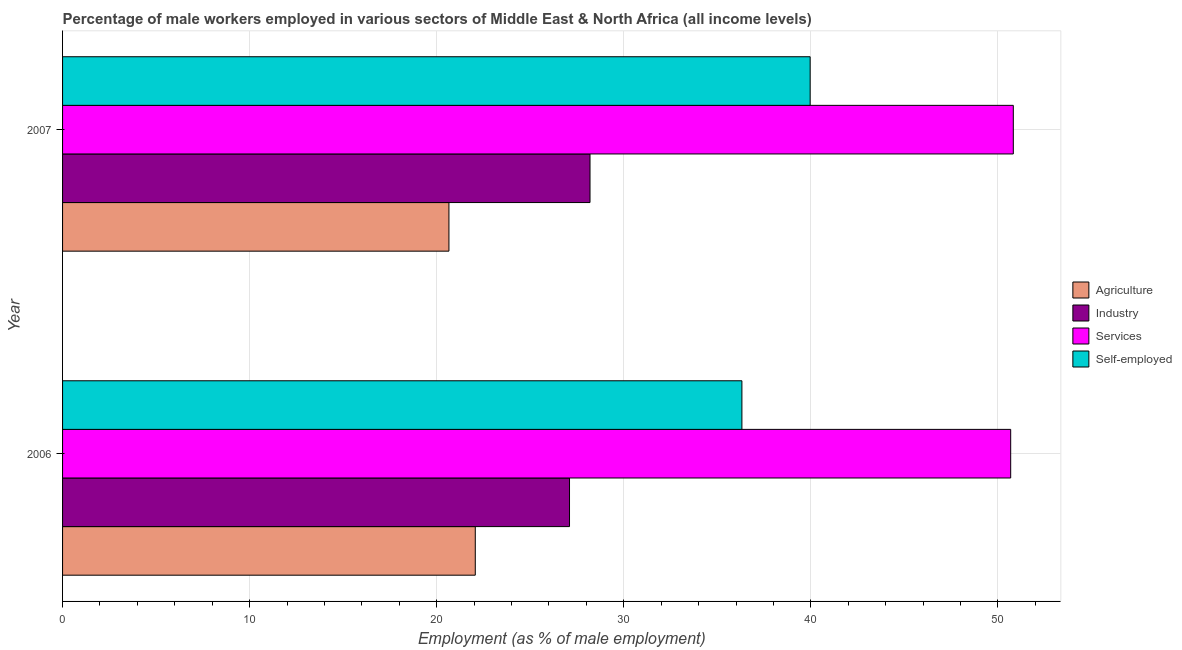How many different coloured bars are there?
Provide a succinct answer. 4. How many groups of bars are there?
Give a very brief answer. 2. How many bars are there on the 1st tick from the top?
Your answer should be compact. 4. What is the label of the 1st group of bars from the top?
Your answer should be very brief. 2007. What is the percentage of male workers in industry in 2006?
Make the answer very short. 27.1. Across all years, what is the maximum percentage of self employed male workers?
Provide a short and direct response. 39.96. Across all years, what is the minimum percentage of male workers in industry?
Your answer should be very brief. 27.1. What is the total percentage of male workers in agriculture in the graph?
Provide a short and direct response. 42.72. What is the difference between the percentage of self employed male workers in 2006 and that in 2007?
Keep it short and to the point. -3.65. What is the difference between the percentage of male workers in agriculture in 2006 and the percentage of male workers in services in 2007?
Your answer should be compact. -28.76. What is the average percentage of male workers in industry per year?
Provide a succinct answer. 27.65. In the year 2006, what is the difference between the percentage of male workers in industry and percentage of male workers in agriculture?
Make the answer very short. 5.04. What is the ratio of the percentage of self employed male workers in 2006 to that in 2007?
Provide a succinct answer. 0.91. Is the percentage of male workers in industry in 2006 less than that in 2007?
Provide a succinct answer. Yes. Is the difference between the percentage of male workers in services in 2006 and 2007 greater than the difference between the percentage of male workers in agriculture in 2006 and 2007?
Your answer should be very brief. No. Is it the case that in every year, the sum of the percentage of male workers in services and percentage of self employed male workers is greater than the sum of percentage of male workers in industry and percentage of male workers in agriculture?
Your answer should be compact. Yes. What does the 3rd bar from the top in 2006 represents?
Offer a very short reply. Industry. What does the 4th bar from the bottom in 2006 represents?
Provide a short and direct response. Self-employed. How many years are there in the graph?
Offer a very short reply. 2. What is the difference between two consecutive major ticks on the X-axis?
Your answer should be very brief. 10. Does the graph contain grids?
Make the answer very short. Yes. Where does the legend appear in the graph?
Provide a short and direct response. Center right. How many legend labels are there?
Make the answer very short. 4. What is the title of the graph?
Keep it short and to the point. Percentage of male workers employed in various sectors of Middle East & North Africa (all income levels). What is the label or title of the X-axis?
Ensure brevity in your answer.  Employment (as % of male employment). What is the label or title of the Y-axis?
Make the answer very short. Year. What is the Employment (as % of male employment) of Agriculture in 2006?
Give a very brief answer. 22.06. What is the Employment (as % of male employment) in Industry in 2006?
Keep it short and to the point. 27.1. What is the Employment (as % of male employment) in Services in 2006?
Provide a short and direct response. 50.68. What is the Employment (as % of male employment) in Self-employed in 2006?
Ensure brevity in your answer.  36.31. What is the Employment (as % of male employment) of Agriculture in 2007?
Your answer should be very brief. 20.65. What is the Employment (as % of male employment) in Industry in 2007?
Keep it short and to the point. 28.19. What is the Employment (as % of male employment) in Services in 2007?
Your response must be concise. 50.82. What is the Employment (as % of male employment) of Self-employed in 2007?
Keep it short and to the point. 39.96. Across all years, what is the maximum Employment (as % of male employment) in Agriculture?
Ensure brevity in your answer.  22.06. Across all years, what is the maximum Employment (as % of male employment) in Industry?
Offer a very short reply. 28.19. Across all years, what is the maximum Employment (as % of male employment) in Services?
Your answer should be very brief. 50.82. Across all years, what is the maximum Employment (as % of male employment) in Self-employed?
Offer a terse response. 39.96. Across all years, what is the minimum Employment (as % of male employment) of Agriculture?
Your answer should be compact. 20.65. Across all years, what is the minimum Employment (as % of male employment) in Industry?
Offer a terse response. 27.1. Across all years, what is the minimum Employment (as % of male employment) of Services?
Make the answer very short. 50.68. Across all years, what is the minimum Employment (as % of male employment) in Self-employed?
Your answer should be very brief. 36.31. What is the total Employment (as % of male employment) of Agriculture in the graph?
Offer a very short reply. 42.72. What is the total Employment (as % of male employment) of Industry in the graph?
Your answer should be compact. 55.29. What is the total Employment (as % of male employment) in Services in the graph?
Provide a succinct answer. 101.5. What is the total Employment (as % of male employment) of Self-employed in the graph?
Provide a short and direct response. 76.28. What is the difference between the Employment (as % of male employment) in Agriculture in 2006 and that in 2007?
Your answer should be very brief. 1.41. What is the difference between the Employment (as % of male employment) of Industry in 2006 and that in 2007?
Your answer should be very brief. -1.1. What is the difference between the Employment (as % of male employment) of Services in 2006 and that in 2007?
Offer a terse response. -0.14. What is the difference between the Employment (as % of male employment) in Self-employed in 2006 and that in 2007?
Ensure brevity in your answer.  -3.65. What is the difference between the Employment (as % of male employment) in Agriculture in 2006 and the Employment (as % of male employment) in Industry in 2007?
Keep it short and to the point. -6.13. What is the difference between the Employment (as % of male employment) of Agriculture in 2006 and the Employment (as % of male employment) of Services in 2007?
Your answer should be compact. -28.76. What is the difference between the Employment (as % of male employment) of Agriculture in 2006 and the Employment (as % of male employment) of Self-employed in 2007?
Your answer should be very brief. -17.9. What is the difference between the Employment (as % of male employment) of Industry in 2006 and the Employment (as % of male employment) of Services in 2007?
Your answer should be compact. -23.72. What is the difference between the Employment (as % of male employment) of Industry in 2006 and the Employment (as % of male employment) of Self-employed in 2007?
Offer a terse response. -12.86. What is the difference between the Employment (as % of male employment) of Services in 2006 and the Employment (as % of male employment) of Self-employed in 2007?
Offer a very short reply. 10.72. What is the average Employment (as % of male employment) in Agriculture per year?
Give a very brief answer. 21.36. What is the average Employment (as % of male employment) of Industry per year?
Keep it short and to the point. 27.65. What is the average Employment (as % of male employment) of Services per year?
Offer a very short reply. 50.75. What is the average Employment (as % of male employment) of Self-employed per year?
Ensure brevity in your answer.  38.14. In the year 2006, what is the difference between the Employment (as % of male employment) of Agriculture and Employment (as % of male employment) of Industry?
Your answer should be very brief. -5.04. In the year 2006, what is the difference between the Employment (as % of male employment) of Agriculture and Employment (as % of male employment) of Services?
Provide a short and direct response. -28.62. In the year 2006, what is the difference between the Employment (as % of male employment) in Agriculture and Employment (as % of male employment) in Self-employed?
Your answer should be very brief. -14.25. In the year 2006, what is the difference between the Employment (as % of male employment) of Industry and Employment (as % of male employment) of Services?
Keep it short and to the point. -23.58. In the year 2006, what is the difference between the Employment (as % of male employment) in Industry and Employment (as % of male employment) in Self-employed?
Offer a very short reply. -9.21. In the year 2006, what is the difference between the Employment (as % of male employment) of Services and Employment (as % of male employment) of Self-employed?
Offer a very short reply. 14.37. In the year 2007, what is the difference between the Employment (as % of male employment) in Agriculture and Employment (as % of male employment) in Industry?
Your response must be concise. -7.54. In the year 2007, what is the difference between the Employment (as % of male employment) in Agriculture and Employment (as % of male employment) in Services?
Your answer should be compact. -30.17. In the year 2007, what is the difference between the Employment (as % of male employment) of Agriculture and Employment (as % of male employment) of Self-employed?
Offer a very short reply. -19.31. In the year 2007, what is the difference between the Employment (as % of male employment) in Industry and Employment (as % of male employment) in Services?
Make the answer very short. -22.63. In the year 2007, what is the difference between the Employment (as % of male employment) of Industry and Employment (as % of male employment) of Self-employed?
Make the answer very short. -11.77. In the year 2007, what is the difference between the Employment (as % of male employment) of Services and Employment (as % of male employment) of Self-employed?
Give a very brief answer. 10.86. What is the ratio of the Employment (as % of male employment) of Agriculture in 2006 to that in 2007?
Provide a short and direct response. 1.07. What is the ratio of the Employment (as % of male employment) in Industry in 2006 to that in 2007?
Ensure brevity in your answer.  0.96. What is the ratio of the Employment (as % of male employment) in Self-employed in 2006 to that in 2007?
Give a very brief answer. 0.91. What is the difference between the highest and the second highest Employment (as % of male employment) of Agriculture?
Make the answer very short. 1.41. What is the difference between the highest and the second highest Employment (as % of male employment) in Industry?
Provide a succinct answer. 1.1. What is the difference between the highest and the second highest Employment (as % of male employment) in Services?
Provide a succinct answer. 0.14. What is the difference between the highest and the second highest Employment (as % of male employment) in Self-employed?
Your response must be concise. 3.65. What is the difference between the highest and the lowest Employment (as % of male employment) in Agriculture?
Your answer should be compact. 1.41. What is the difference between the highest and the lowest Employment (as % of male employment) of Industry?
Make the answer very short. 1.1. What is the difference between the highest and the lowest Employment (as % of male employment) in Services?
Offer a very short reply. 0.14. What is the difference between the highest and the lowest Employment (as % of male employment) in Self-employed?
Provide a succinct answer. 3.65. 